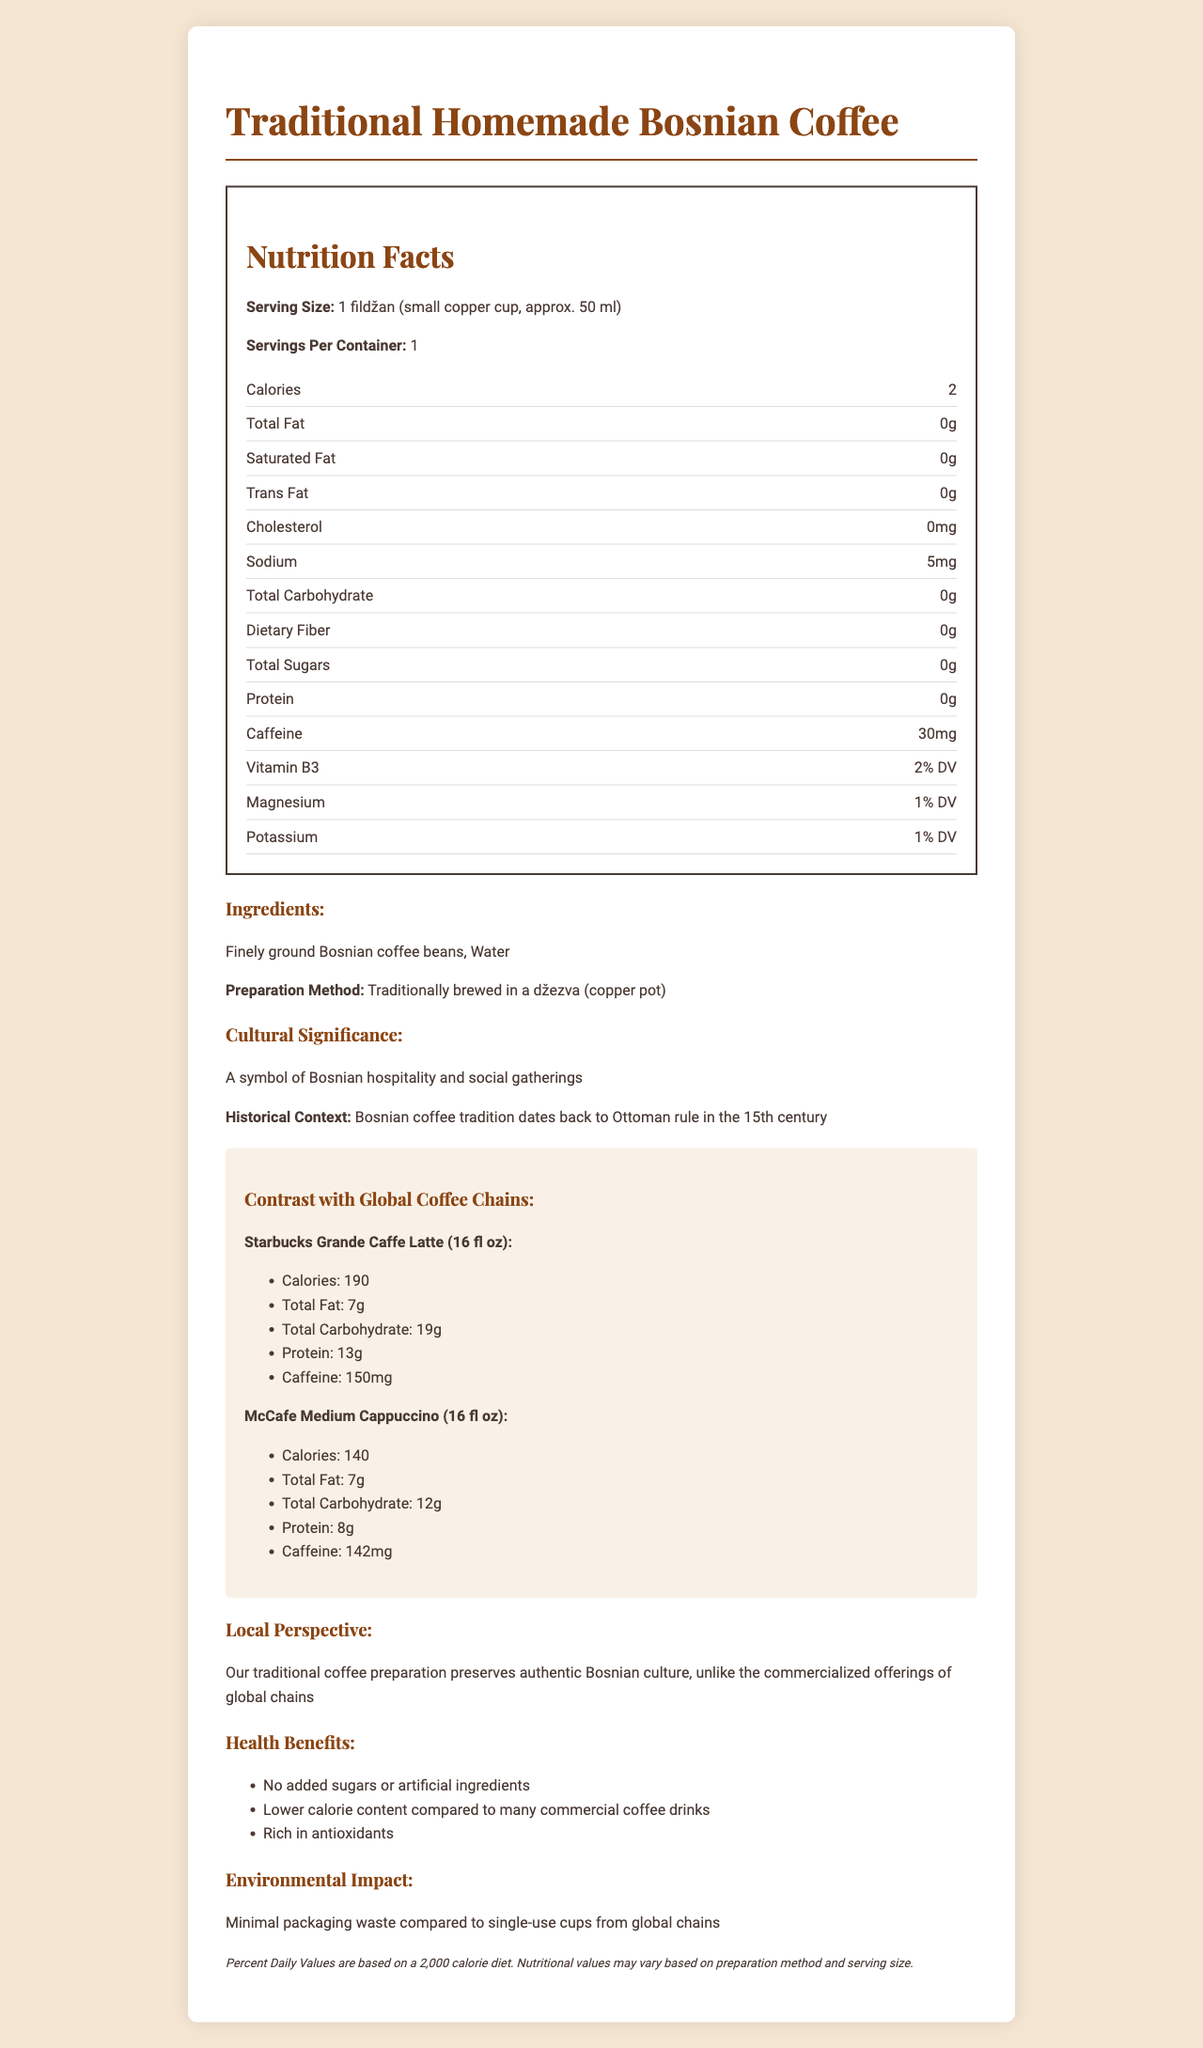how many calories are in a serving of Traditional Homemade Bosnian Coffee? The document mentions that Traditional Homemade Bosnian Coffee has 2 calories per serving.
Answer: 2 what is the serving size of Traditional Homemade Bosnian Coffee? The serving size is specified as 1 fildžan, which is a small copper cup, approximately 50 ml.
Answer: 1 fildžan (small copper cup, approx. 50 ml) how much caffeine does a serving of Traditional Homemade Bosnian Coffee contain? The document states that a serving contains 30 mg of caffeine.
Answer: 30 mg what are the ingredients in Traditional Homemade Bosnian Coffee? The ingredients listed are finely ground Bosnian coffee beans and water.
Answer: Finely ground Bosnian coffee beans, Water what is the traditional preparation method for Bosnian coffee? The document indicates that Bosnian coffee is traditionally brewed in a džezva, a copper pot.
Answer: Traditionally brewed in a džezva (copper pot) how many calories are in a Starbucks Grande Caffe Latte? According to the document, a Starbucks Grande Caffe Latte contains 190 calories.
Answer: 190 which global coffee chain offering has the highest caffeine content per serving? A. Starbucks Grande Caffe Latte B. McCafe Medium Cappuccino C. Traditional Homemade Bosnian Coffee The document indicates that Starbucks Grande Caffe Latte has 150 mg of caffeine, which is higher than McCafe Medium Cappuccino (142 mg) and Traditional Homemade Bosnian Coffee (30 mg).
Answer: A how does the calorie content of Traditional Homemade Bosnian Coffee compare to McCafe Medium Cappuccino? A. Lower B. Higher C. The same Traditional Homemade Bosnian coffee has 2 calories, which is significantly lower than McCafe Medium Cappuccino's 140 calories.
Answer: A do Traditional Homemade Bosnian Coffee contain any added sugars or artificial ingredients? The document mentions that one of the health benefits of Traditional Homemade Bosnian coffee is that it has no added sugars or artificial ingredients.
Answer: No is the serving size of Traditional Homemade Bosnian Coffee smaller than that of the global coffee chain offerings mentioned? The serving size of Traditional Homemade Bosnian Coffee is 50 ml, which is smaller compared to the 473 ml serving sizes of the global coffee chain offerings.
Answer: Yes what historical context is provided for Bosnian coffee? The document mentions that the tradition of Bosnian coffee dates back to the 15th century during Ottoman rule.
Answer: Bosnian coffee tradition dates back to Ottoman rule in the 15th century. what are some health benefits of Traditional Homemade Bosnian Coffee mentioned in the document? The health benefits listed include no added sugars or artificial ingredients, lower calorie content compared to many commercial coffee drinks, and being rich in antioxidants.
Answer: No added sugars or artificial ingredients, Lower calorie content compared to many commercial coffee drinks, Rich in antioxidants describe the cultural significance of Traditional Homemade Bosnian Coffee mentioned in the document. The document states that Bosnian coffee is a symbol of hospitality and social gatherings in Bosnia.
Answer: A symbol of Bosnian hospitality and social gatherings based on the document, can we determine the exact amount of vitamin B3 in a serving of Traditional Homemade Bosnian Coffee? The document only indicates that it provides 2% of the daily value (DV) of vitamin B3 but does not specify the exact amount.
Answer: Not enough information summarize the main idea of the document. The detailed description includes nutrition facts, traditional preparation methods, cultural significance, comparisons with global coffee chain products, health benefits, and environmental impacts, focusing on the preservation of Bosnian culture through traditional coffee.
Answer: The document provides detailed nutrition facts about Traditional Homemade Bosnian Coffee, highlighting its low calorie and natural content, its cultural significance, contrasts with global coffee chain offerings, and its environmental and health benefits. 